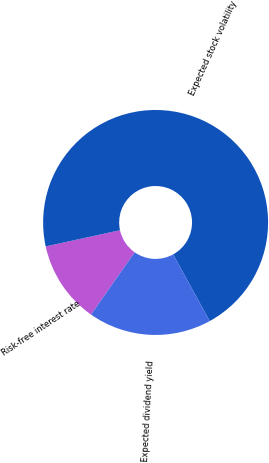<chart> <loc_0><loc_0><loc_500><loc_500><pie_chart><fcel>Risk-free interest rate<fcel>Expected stock volatility<fcel>Expected dividend yield<nl><fcel>11.85%<fcel>70.43%<fcel>17.72%<nl></chart> 